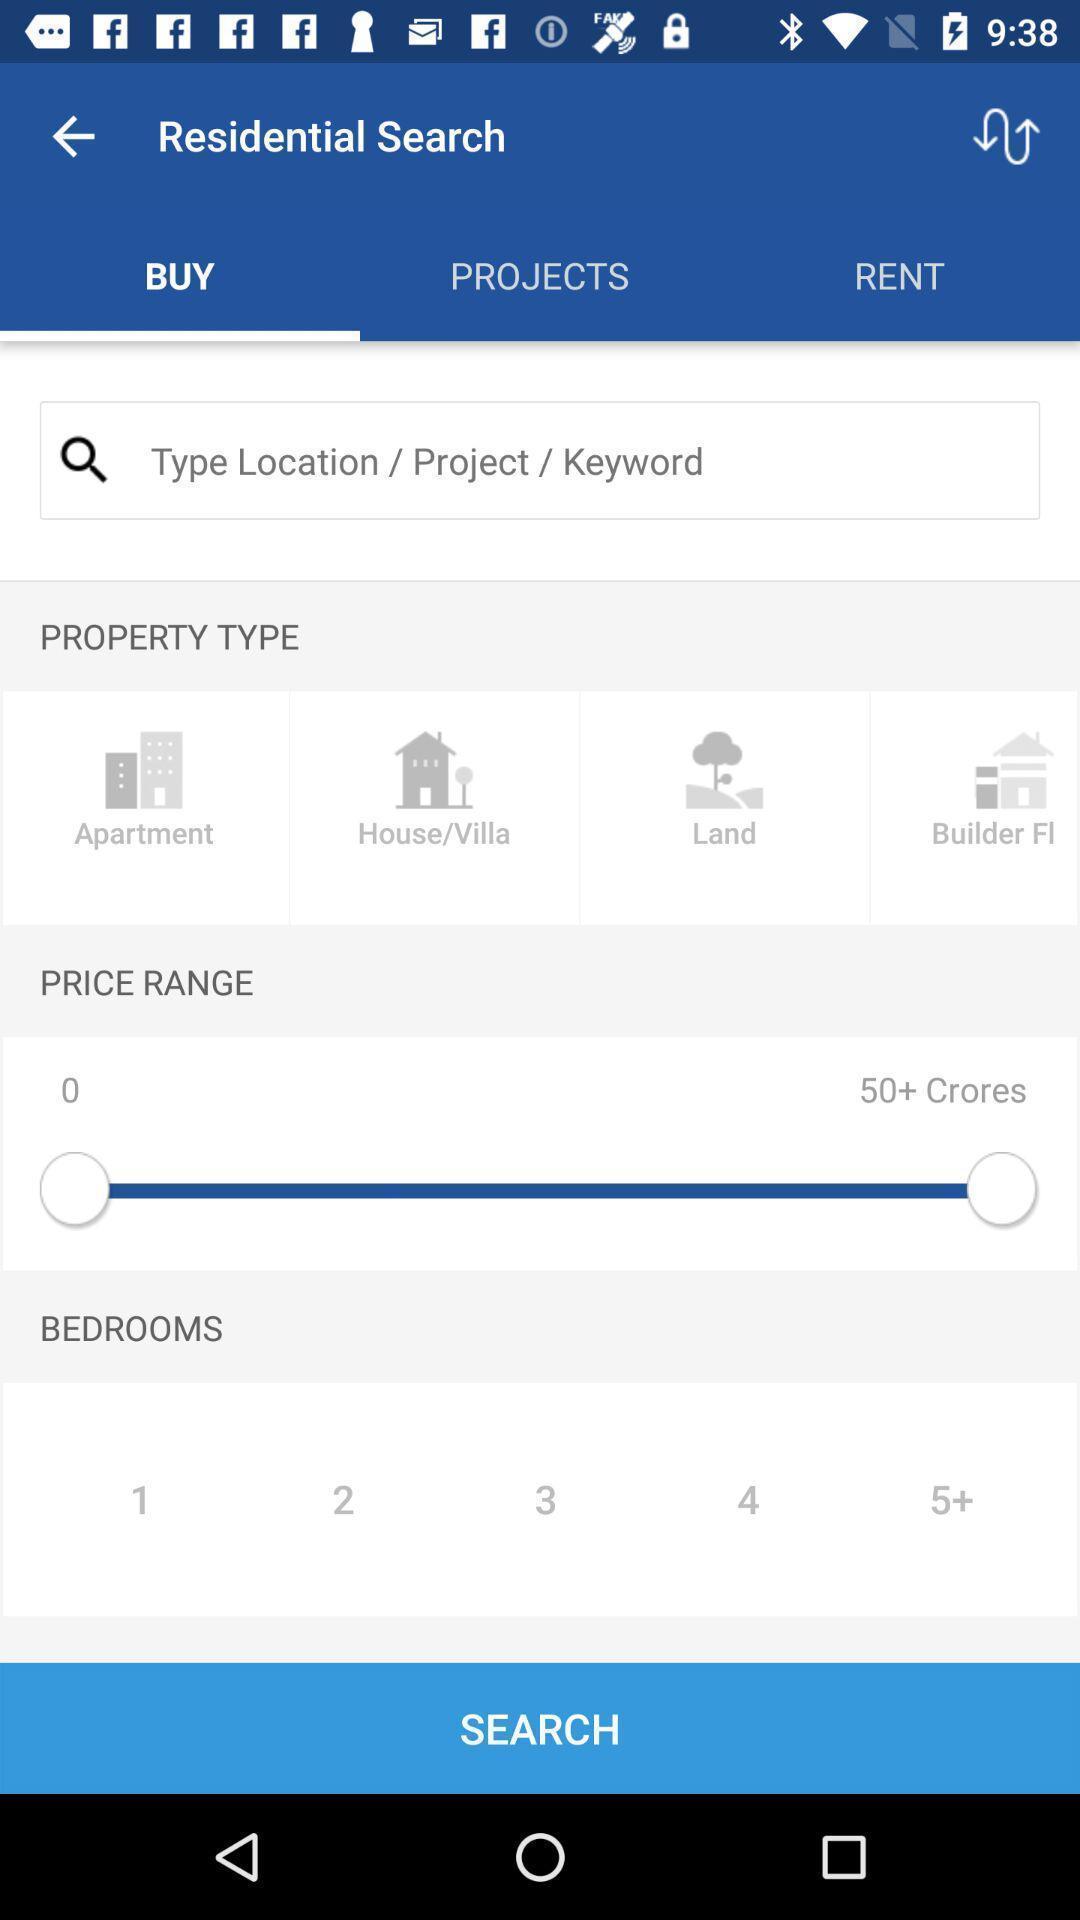Describe this image in words. Screen shows residential details. 